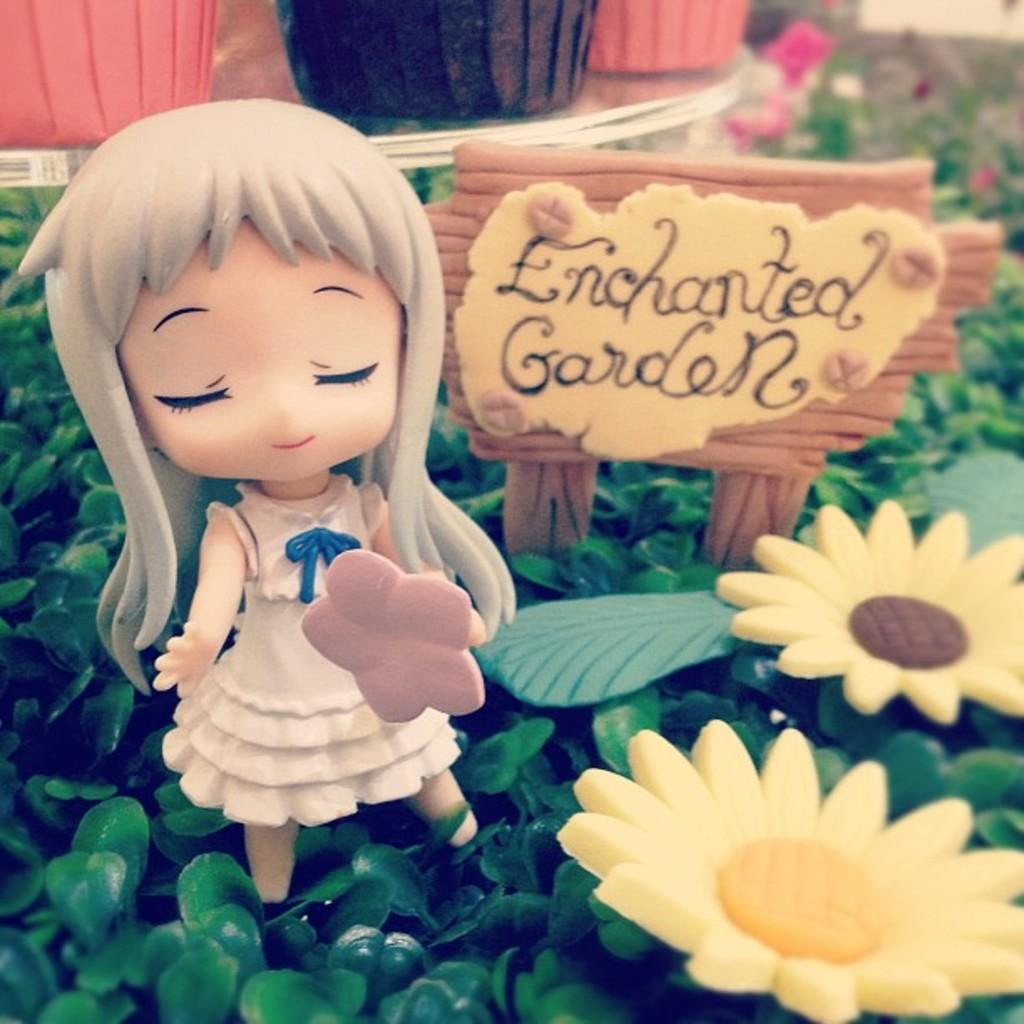What type of toy is present in the image? There is a girl toy in the image. Where is the girl toy located? The girl toy is placed among plants with flowers. What else can be seen in the image besides the girl toy? There is a board and plants with flowers in the background. What is present in the left top part of the image? There is a table with pots on it in the left top part of the image. What type of decision does the girl toy make in the image? There is no indication in the image that the girl toy is making any decisions, as it is an inanimate object. Can you see any soda in the image? There is no soda present in the image. 